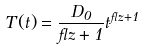Convert formula to latex. <formula><loc_0><loc_0><loc_500><loc_500>T ( t ) = \frac { D _ { 0 } } { \gamma z + 1 } t ^ { \gamma z + 1 }</formula> 